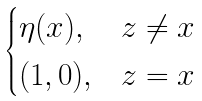Convert formula to latex. <formula><loc_0><loc_0><loc_500><loc_500>\begin{cases} \eta ( x ) , & z \ne x \\ ( 1 , 0 ) , & z = x \end{cases}</formula> 